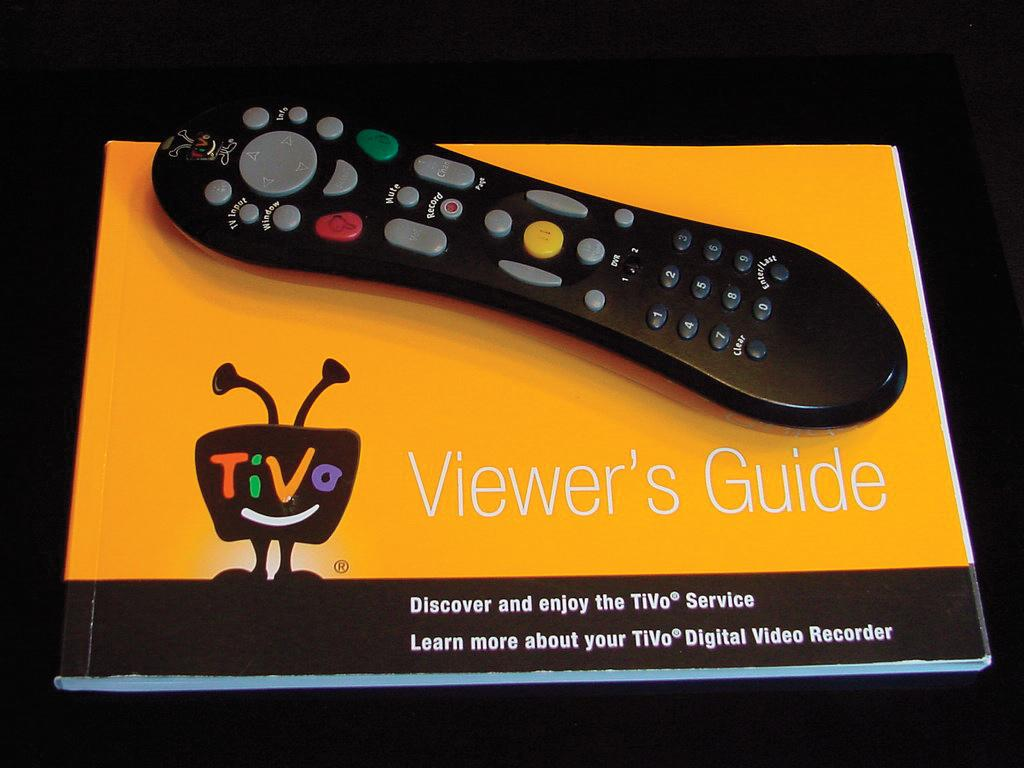<image>
Summarize the visual content of the image. A remote control on top of a Viewer's Guide booklet for Tivo 